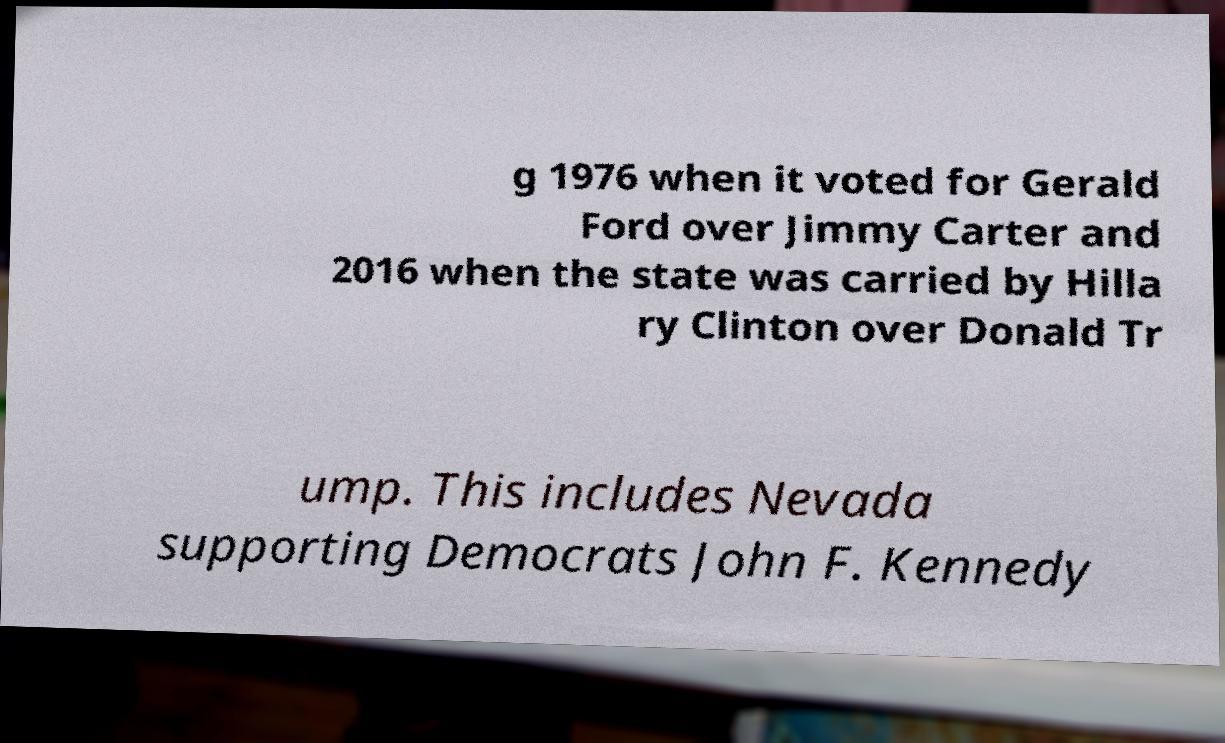For documentation purposes, I need the text within this image transcribed. Could you provide that? g 1976 when it voted for Gerald Ford over Jimmy Carter and 2016 when the state was carried by Hilla ry Clinton over Donald Tr ump. This includes Nevada supporting Democrats John F. Kennedy 